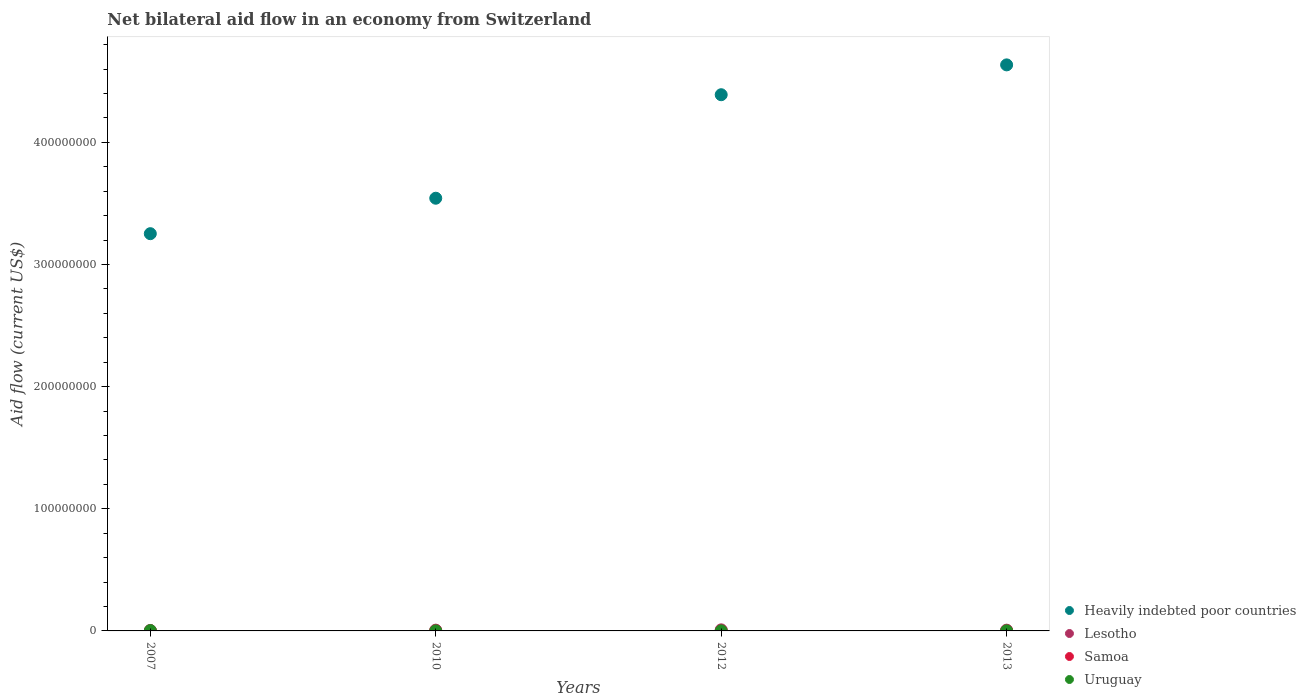How many different coloured dotlines are there?
Give a very brief answer. 4. Is the number of dotlines equal to the number of legend labels?
Give a very brief answer. Yes. What is the net bilateral aid flow in Uruguay in 2010?
Your answer should be very brief. 4.00e+04. Across all years, what is the maximum net bilateral aid flow in Uruguay?
Make the answer very short. 2.70e+05. In which year was the net bilateral aid flow in Lesotho maximum?
Provide a short and direct response. 2012. In which year was the net bilateral aid flow in Uruguay minimum?
Ensure brevity in your answer.  2010. What is the total net bilateral aid flow in Samoa in the graph?
Offer a very short reply. 9.00e+04. What is the difference between the net bilateral aid flow in Samoa in 2007 and the net bilateral aid flow in Uruguay in 2012?
Ensure brevity in your answer.  -4.00e+04. What is the average net bilateral aid flow in Uruguay per year?
Ensure brevity in your answer.  1.08e+05. In how many years, is the net bilateral aid flow in Uruguay greater than 240000000 US$?
Provide a succinct answer. 0. What is the ratio of the net bilateral aid flow in Uruguay in 2010 to that in 2012?
Offer a very short reply. 0.67. Is the net bilateral aid flow in Heavily indebted poor countries in 2010 less than that in 2012?
Offer a terse response. Yes. Is the difference between the net bilateral aid flow in Samoa in 2010 and 2013 greater than the difference between the net bilateral aid flow in Uruguay in 2010 and 2013?
Keep it short and to the point. Yes. What is the difference between the highest and the second highest net bilateral aid flow in Heavily indebted poor countries?
Keep it short and to the point. 2.44e+07. What is the difference between the highest and the lowest net bilateral aid flow in Uruguay?
Your response must be concise. 2.30e+05. In how many years, is the net bilateral aid flow in Heavily indebted poor countries greater than the average net bilateral aid flow in Heavily indebted poor countries taken over all years?
Make the answer very short. 2. Is the sum of the net bilateral aid flow in Heavily indebted poor countries in 2007 and 2010 greater than the maximum net bilateral aid flow in Uruguay across all years?
Ensure brevity in your answer.  Yes. Is it the case that in every year, the sum of the net bilateral aid flow in Uruguay and net bilateral aid flow in Lesotho  is greater than the sum of net bilateral aid flow in Heavily indebted poor countries and net bilateral aid flow in Samoa?
Make the answer very short. Yes. Is it the case that in every year, the sum of the net bilateral aid flow in Uruguay and net bilateral aid flow in Lesotho  is greater than the net bilateral aid flow in Heavily indebted poor countries?
Provide a succinct answer. No. How many dotlines are there?
Keep it short and to the point. 4. How many years are there in the graph?
Offer a very short reply. 4. Does the graph contain grids?
Your response must be concise. No. Where does the legend appear in the graph?
Provide a short and direct response. Bottom right. How many legend labels are there?
Offer a terse response. 4. What is the title of the graph?
Your answer should be very brief. Net bilateral aid flow in an economy from Switzerland. Does "Cambodia" appear as one of the legend labels in the graph?
Keep it short and to the point. No. What is the label or title of the Y-axis?
Ensure brevity in your answer.  Aid flow (current US$). What is the Aid flow (current US$) of Heavily indebted poor countries in 2007?
Make the answer very short. 3.25e+08. What is the Aid flow (current US$) of Lesotho in 2007?
Your answer should be compact. 3.80e+05. What is the Aid flow (current US$) of Heavily indebted poor countries in 2010?
Offer a very short reply. 3.54e+08. What is the Aid flow (current US$) in Lesotho in 2010?
Provide a short and direct response. 6.30e+05. What is the Aid flow (current US$) in Heavily indebted poor countries in 2012?
Make the answer very short. 4.39e+08. What is the Aid flow (current US$) of Lesotho in 2012?
Keep it short and to the point. 8.80e+05. What is the Aid flow (current US$) of Samoa in 2012?
Offer a very short reply. 10000. What is the Aid flow (current US$) in Heavily indebted poor countries in 2013?
Make the answer very short. 4.63e+08. What is the Aid flow (current US$) in Lesotho in 2013?
Your answer should be very brief. 6.20e+05. What is the Aid flow (current US$) of Uruguay in 2013?
Your answer should be very brief. 6.00e+04. Across all years, what is the maximum Aid flow (current US$) of Heavily indebted poor countries?
Provide a short and direct response. 4.63e+08. Across all years, what is the maximum Aid flow (current US$) of Lesotho?
Offer a very short reply. 8.80e+05. Across all years, what is the minimum Aid flow (current US$) of Heavily indebted poor countries?
Provide a succinct answer. 3.25e+08. Across all years, what is the minimum Aid flow (current US$) in Samoa?
Give a very brief answer. 10000. Across all years, what is the minimum Aid flow (current US$) of Uruguay?
Ensure brevity in your answer.  4.00e+04. What is the total Aid flow (current US$) in Heavily indebted poor countries in the graph?
Your response must be concise. 1.58e+09. What is the total Aid flow (current US$) in Lesotho in the graph?
Ensure brevity in your answer.  2.51e+06. What is the total Aid flow (current US$) of Uruguay in the graph?
Your answer should be very brief. 4.30e+05. What is the difference between the Aid flow (current US$) in Heavily indebted poor countries in 2007 and that in 2010?
Ensure brevity in your answer.  -2.90e+07. What is the difference between the Aid flow (current US$) in Samoa in 2007 and that in 2010?
Provide a short and direct response. -3.00e+04. What is the difference between the Aid flow (current US$) in Uruguay in 2007 and that in 2010?
Offer a terse response. 2.30e+05. What is the difference between the Aid flow (current US$) of Heavily indebted poor countries in 2007 and that in 2012?
Your answer should be very brief. -1.14e+08. What is the difference between the Aid flow (current US$) in Lesotho in 2007 and that in 2012?
Your answer should be very brief. -5.00e+05. What is the difference between the Aid flow (current US$) of Uruguay in 2007 and that in 2012?
Offer a terse response. 2.10e+05. What is the difference between the Aid flow (current US$) of Heavily indebted poor countries in 2007 and that in 2013?
Ensure brevity in your answer.  -1.38e+08. What is the difference between the Aid flow (current US$) in Samoa in 2007 and that in 2013?
Offer a very short reply. 10000. What is the difference between the Aid flow (current US$) in Heavily indebted poor countries in 2010 and that in 2012?
Your answer should be very brief. -8.47e+07. What is the difference between the Aid flow (current US$) in Heavily indebted poor countries in 2010 and that in 2013?
Provide a short and direct response. -1.09e+08. What is the difference between the Aid flow (current US$) of Heavily indebted poor countries in 2012 and that in 2013?
Provide a short and direct response. -2.44e+07. What is the difference between the Aid flow (current US$) in Lesotho in 2012 and that in 2013?
Your answer should be very brief. 2.60e+05. What is the difference between the Aid flow (current US$) of Heavily indebted poor countries in 2007 and the Aid flow (current US$) of Lesotho in 2010?
Your answer should be very brief. 3.25e+08. What is the difference between the Aid flow (current US$) of Heavily indebted poor countries in 2007 and the Aid flow (current US$) of Samoa in 2010?
Your answer should be compact. 3.25e+08. What is the difference between the Aid flow (current US$) in Heavily indebted poor countries in 2007 and the Aid flow (current US$) in Uruguay in 2010?
Give a very brief answer. 3.25e+08. What is the difference between the Aid flow (current US$) in Lesotho in 2007 and the Aid flow (current US$) in Uruguay in 2010?
Your answer should be very brief. 3.40e+05. What is the difference between the Aid flow (current US$) of Heavily indebted poor countries in 2007 and the Aid flow (current US$) of Lesotho in 2012?
Your response must be concise. 3.24e+08. What is the difference between the Aid flow (current US$) in Heavily indebted poor countries in 2007 and the Aid flow (current US$) in Samoa in 2012?
Offer a very short reply. 3.25e+08. What is the difference between the Aid flow (current US$) of Heavily indebted poor countries in 2007 and the Aid flow (current US$) of Uruguay in 2012?
Make the answer very short. 3.25e+08. What is the difference between the Aid flow (current US$) in Lesotho in 2007 and the Aid flow (current US$) in Uruguay in 2012?
Your response must be concise. 3.20e+05. What is the difference between the Aid flow (current US$) of Heavily indebted poor countries in 2007 and the Aid flow (current US$) of Lesotho in 2013?
Ensure brevity in your answer.  3.25e+08. What is the difference between the Aid flow (current US$) in Heavily indebted poor countries in 2007 and the Aid flow (current US$) in Samoa in 2013?
Make the answer very short. 3.25e+08. What is the difference between the Aid flow (current US$) in Heavily indebted poor countries in 2007 and the Aid flow (current US$) in Uruguay in 2013?
Make the answer very short. 3.25e+08. What is the difference between the Aid flow (current US$) of Lesotho in 2007 and the Aid flow (current US$) of Samoa in 2013?
Provide a succinct answer. 3.70e+05. What is the difference between the Aid flow (current US$) in Samoa in 2007 and the Aid flow (current US$) in Uruguay in 2013?
Keep it short and to the point. -4.00e+04. What is the difference between the Aid flow (current US$) of Heavily indebted poor countries in 2010 and the Aid flow (current US$) of Lesotho in 2012?
Your response must be concise. 3.53e+08. What is the difference between the Aid flow (current US$) of Heavily indebted poor countries in 2010 and the Aid flow (current US$) of Samoa in 2012?
Ensure brevity in your answer.  3.54e+08. What is the difference between the Aid flow (current US$) of Heavily indebted poor countries in 2010 and the Aid flow (current US$) of Uruguay in 2012?
Make the answer very short. 3.54e+08. What is the difference between the Aid flow (current US$) of Lesotho in 2010 and the Aid flow (current US$) of Samoa in 2012?
Provide a succinct answer. 6.20e+05. What is the difference between the Aid flow (current US$) in Lesotho in 2010 and the Aid flow (current US$) in Uruguay in 2012?
Give a very brief answer. 5.70e+05. What is the difference between the Aid flow (current US$) of Samoa in 2010 and the Aid flow (current US$) of Uruguay in 2012?
Give a very brief answer. -10000. What is the difference between the Aid flow (current US$) of Heavily indebted poor countries in 2010 and the Aid flow (current US$) of Lesotho in 2013?
Give a very brief answer. 3.54e+08. What is the difference between the Aid flow (current US$) in Heavily indebted poor countries in 2010 and the Aid flow (current US$) in Samoa in 2013?
Your response must be concise. 3.54e+08. What is the difference between the Aid flow (current US$) in Heavily indebted poor countries in 2010 and the Aid flow (current US$) in Uruguay in 2013?
Your response must be concise. 3.54e+08. What is the difference between the Aid flow (current US$) in Lesotho in 2010 and the Aid flow (current US$) in Samoa in 2013?
Your answer should be very brief. 6.20e+05. What is the difference between the Aid flow (current US$) in Lesotho in 2010 and the Aid flow (current US$) in Uruguay in 2013?
Provide a succinct answer. 5.70e+05. What is the difference between the Aid flow (current US$) of Samoa in 2010 and the Aid flow (current US$) of Uruguay in 2013?
Your answer should be compact. -10000. What is the difference between the Aid flow (current US$) in Heavily indebted poor countries in 2012 and the Aid flow (current US$) in Lesotho in 2013?
Make the answer very short. 4.38e+08. What is the difference between the Aid flow (current US$) of Heavily indebted poor countries in 2012 and the Aid flow (current US$) of Samoa in 2013?
Give a very brief answer. 4.39e+08. What is the difference between the Aid flow (current US$) of Heavily indebted poor countries in 2012 and the Aid flow (current US$) of Uruguay in 2013?
Provide a short and direct response. 4.39e+08. What is the difference between the Aid flow (current US$) of Lesotho in 2012 and the Aid flow (current US$) of Samoa in 2013?
Your answer should be very brief. 8.70e+05. What is the difference between the Aid flow (current US$) in Lesotho in 2012 and the Aid flow (current US$) in Uruguay in 2013?
Keep it short and to the point. 8.20e+05. What is the difference between the Aid flow (current US$) in Samoa in 2012 and the Aid flow (current US$) in Uruguay in 2013?
Offer a terse response. -5.00e+04. What is the average Aid flow (current US$) of Heavily indebted poor countries per year?
Offer a very short reply. 3.96e+08. What is the average Aid flow (current US$) of Lesotho per year?
Make the answer very short. 6.28e+05. What is the average Aid flow (current US$) of Samoa per year?
Ensure brevity in your answer.  2.25e+04. What is the average Aid flow (current US$) in Uruguay per year?
Make the answer very short. 1.08e+05. In the year 2007, what is the difference between the Aid flow (current US$) in Heavily indebted poor countries and Aid flow (current US$) in Lesotho?
Provide a short and direct response. 3.25e+08. In the year 2007, what is the difference between the Aid flow (current US$) in Heavily indebted poor countries and Aid flow (current US$) in Samoa?
Give a very brief answer. 3.25e+08. In the year 2007, what is the difference between the Aid flow (current US$) of Heavily indebted poor countries and Aid flow (current US$) of Uruguay?
Your response must be concise. 3.25e+08. In the year 2007, what is the difference between the Aid flow (current US$) of Samoa and Aid flow (current US$) of Uruguay?
Ensure brevity in your answer.  -2.50e+05. In the year 2010, what is the difference between the Aid flow (current US$) in Heavily indebted poor countries and Aid flow (current US$) in Lesotho?
Your answer should be compact. 3.54e+08. In the year 2010, what is the difference between the Aid flow (current US$) of Heavily indebted poor countries and Aid flow (current US$) of Samoa?
Give a very brief answer. 3.54e+08. In the year 2010, what is the difference between the Aid flow (current US$) of Heavily indebted poor countries and Aid flow (current US$) of Uruguay?
Your answer should be very brief. 3.54e+08. In the year 2010, what is the difference between the Aid flow (current US$) of Lesotho and Aid flow (current US$) of Samoa?
Your answer should be very brief. 5.80e+05. In the year 2010, what is the difference between the Aid flow (current US$) in Lesotho and Aid flow (current US$) in Uruguay?
Ensure brevity in your answer.  5.90e+05. In the year 2012, what is the difference between the Aid flow (current US$) of Heavily indebted poor countries and Aid flow (current US$) of Lesotho?
Your response must be concise. 4.38e+08. In the year 2012, what is the difference between the Aid flow (current US$) in Heavily indebted poor countries and Aid flow (current US$) in Samoa?
Ensure brevity in your answer.  4.39e+08. In the year 2012, what is the difference between the Aid flow (current US$) of Heavily indebted poor countries and Aid flow (current US$) of Uruguay?
Your answer should be compact. 4.39e+08. In the year 2012, what is the difference between the Aid flow (current US$) in Lesotho and Aid flow (current US$) in Samoa?
Keep it short and to the point. 8.70e+05. In the year 2012, what is the difference between the Aid flow (current US$) of Lesotho and Aid flow (current US$) of Uruguay?
Offer a terse response. 8.20e+05. In the year 2012, what is the difference between the Aid flow (current US$) of Samoa and Aid flow (current US$) of Uruguay?
Your response must be concise. -5.00e+04. In the year 2013, what is the difference between the Aid flow (current US$) in Heavily indebted poor countries and Aid flow (current US$) in Lesotho?
Your answer should be very brief. 4.63e+08. In the year 2013, what is the difference between the Aid flow (current US$) of Heavily indebted poor countries and Aid flow (current US$) of Samoa?
Your answer should be compact. 4.63e+08. In the year 2013, what is the difference between the Aid flow (current US$) in Heavily indebted poor countries and Aid flow (current US$) in Uruguay?
Offer a very short reply. 4.63e+08. In the year 2013, what is the difference between the Aid flow (current US$) of Lesotho and Aid flow (current US$) of Uruguay?
Ensure brevity in your answer.  5.60e+05. In the year 2013, what is the difference between the Aid flow (current US$) of Samoa and Aid flow (current US$) of Uruguay?
Your response must be concise. -5.00e+04. What is the ratio of the Aid flow (current US$) in Heavily indebted poor countries in 2007 to that in 2010?
Your response must be concise. 0.92. What is the ratio of the Aid flow (current US$) in Lesotho in 2007 to that in 2010?
Offer a terse response. 0.6. What is the ratio of the Aid flow (current US$) of Uruguay in 2007 to that in 2010?
Keep it short and to the point. 6.75. What is the ratio of the Aid flow (current US$) in Heavily indebted poor countries in 2007 to that in 2012?
Keep it short and to the point. 0.74. What is the ratio of the Aid flow (current US$) of Lesotho in 2007 to that in 2012?
Give a very brief answer. 0.43. What is the ratio of the Aid flow (current US$) in Heavily indebted poor countries in 2007 to that in 2013?
Provide a succinct answer. 0.7. What is the ratio of the Aid flow (current US$) in Lesotho in 2007 to that in 2013?
Your answer should be compact. 0.61. What is the ratio of the Aid flow (current US$) in Samoa in 2007 to that in 2013?
Your answer should be very brief. 2. What is the ratio of the Aid flow (current US$) in Heavily indebted poor countries in 2010 to that in 2012?
Provide a succinct answer. 0.81. What is the ratio of the Aid flow (current US$) in Lesotho in 2010 to that in 2012?
Make the answer very short. 0.72. What is the ratio of the Aid flow (current US$) in Heavily indebted poor countries in 2010 to that in 2013?
Make the answer very short. 0.76. What is the ratio of the Aid flow (current US$) of Lesotho in 2010 to that in 2013?
Your answer should be very brief. 1.02. What is the ratio of the Aid flow (current US$) in Samoa in 2010 to that in 2013?
Make the answer very short. 5. What is the ratio of the Aid flow (current US$) in Heavily indebted poor countries in 2012 to that in 2013?
Offer a very short reply. 0.95. What is the ratio of the Aid flow (current US$) of Lesotho in 2012 to that in 2013?
Offer a very short reply. 1.42. What is the ratio of the Aid flow (current US$) of Samoa in 2012 to that in 2013?
Make the answer very short. 1. What is the difference between the highest and the second highest Aid flow (current US$) in Heavily indebted poor countries?
Your answer should be compact. 2.44e+07. What is the difference between the highest and the second highest Aid flow (current US$) in Samoa?
Your response must be concise. 3.00e+04. What is the difference between the highest and the lowest Aid flow (current US$) of Heavily indebted poor countries?
Keep it short and to the point. 1.38e+08. What is the difference between the highest and the lowest Aid flow (current US$) in Lesotho?
Your answer should be very brief. 5.00e+05. What is the difference between the highest and the lowest Aid flow (current US$) in Samoa?
Provide a short and direct response. 4.00e+04. 